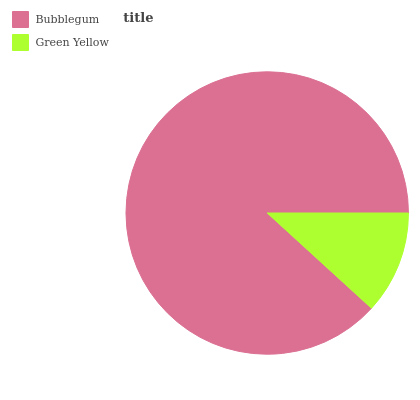Is Green Yellow the minimum?
Answer yes or no. Yes. Is Bubblegum the maximum?
Answer yes or no. Yes. Is Green Yellow the maximum?
Answer yes or no. No. Is Bubblegum greater than Green Yellow?
Answer yes or no. Yes. Is Green Yellow less than Bubblegum?
Answer yes or no. Yes. Is Green Yellow greater than Bubblegum?
Answer yes or no. No. Is Bubblegum less than Green Yellow?
Answer yes or no. No. Is Bubblegum the high median?
Answer yes or no. Yes. Is Green Yellow the low median?
Answer yes or no. Yes. Is Green Yellow the high median?
Answer yes or no. No. Is Bubblegum the low median?
Answer yes or no. No. 